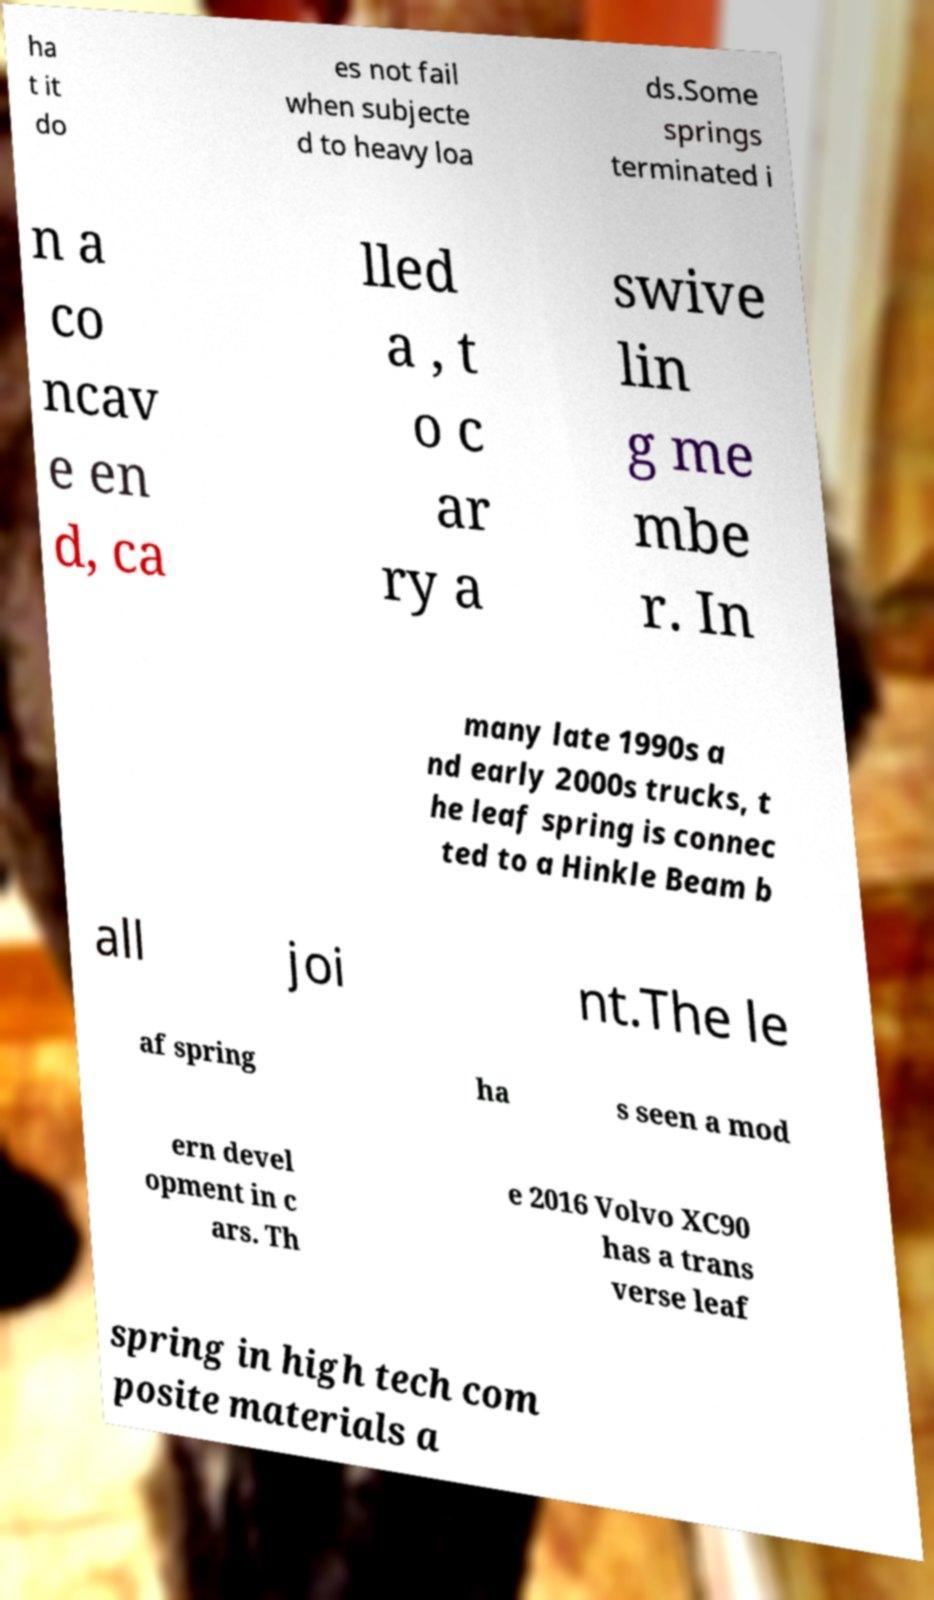I need the written content from this picture converted into text. Can you do that? ha t it do es not fail when subjecte d to heavy loa ds.Some springs terminated i n a co ncav e en d, ca lled a , t o c ar ry a swive lin g me mbe r. In many late 1990s a nd early 2000s trucks, t he leaf spring is connec ted to a Hinkle Beam b all joi nt.The le af spring ha s seen a mod ern devel opment in c ars. Th e 2016 Volvo XC90 has a trans verse leaf spring in high tech com posite materials a 